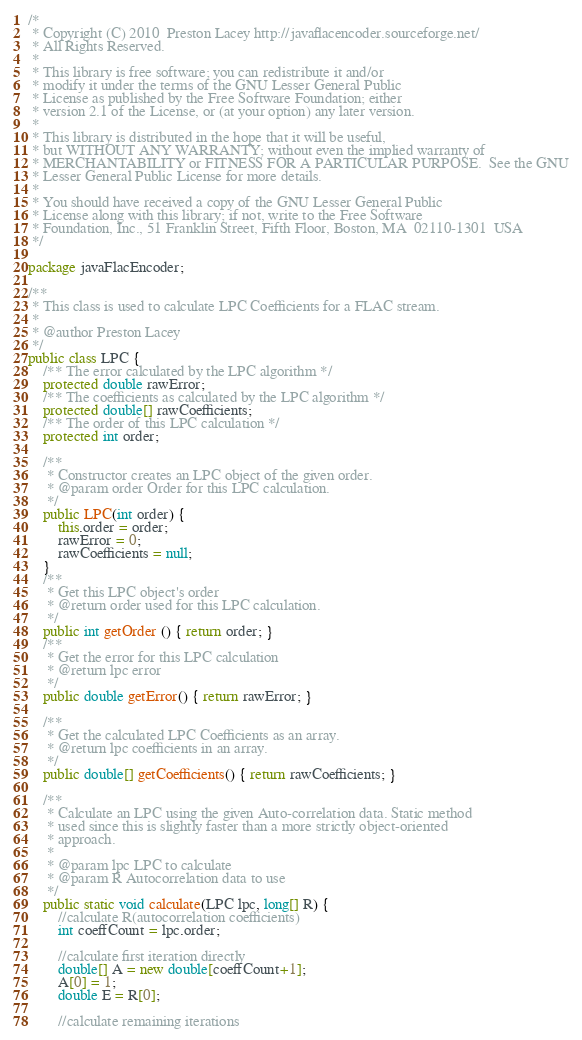<code> <loc_0><loc_0><loc_500><loc_500><_Java_>/*
 * Copyright (C) 2010  Preston Lacey http://javaflacencoder.sourceforge.net/
 * All Rights Reserved.
 *
 * This library is free software; you can redistribute it and/or
 * modify it under the terms of the GNU Lesser General Public
 * License as published by the Free Software Foundation; either
 * version 2.1 of the License, or (at your option) any later version.
 *
 * This library is distributed in the hope that it will be useful,
 * but WITHOUT ANY WARRANTY; without even the implied warranty of
 * MERCHANTABILITY or FITNESS FOR A PARTICULAR PURPOSE.  See the GNU
 * Lesser General Public License for more details.
 *
 * You should have received a copy of the GNU Lesser General Public
 * License along with this library; if not, write to the Free Software
 * Foundation, Inc., 51 Franklin Street, Fifth Floor, Boston, MA  02110-1301  USA
 */

package javaFlacEncoder;

/**
 * This class is used to calculate LPC Coefficients for a FLAC stream.
 *
 * @author Preston Lacey
 */
public class LPC {
    /** The error calculated by the LPC algorithm */
    protected double rawError;
    /** The coefficients as calculated by the LPC algorithm */
    protected double[] rawCoefficients;
    /** The order of this LPC calculation */
    protected int order;

    /**
     * Constructor creates an LPC object of the given order.
     * @param order Order for this LPC calculation.
     */
    public LPC(int order) {
        this.order = order;
        rawError = 0;
        rawCoefficients = null;
    }
    /**
     * Get this LPC object's order
     * @return order used for this LPC calculation.
     */
    public int getOrder () { return order; }
    /**
     * Get the error for this LPC calculation
     * @return lpc error
     */
    public double getError() { return rawError; }

    /**
     * Get the calculated LPC Coefficients as an array.
     * @return lpc coefficients in an array.
     */
    public double[] getCoefficients() { return rawCoefficients; }

    /**
     * Calculate an LPC using the given Auto-correlation data. Static method
     * used since this is slightly faster than a more strictly object-oriented
     * approach.
     * 
     * @param lpc LPC to calculate
     * @param R Autocorrelation data to use
     */
    public static void calculate(LPC lpc, long[] R) {
        //calculate R(autocorrelation coefficients)
        int coeffCount = lpc.order;

        //calculate first iteration directly
        double[] A = new double[coeffCount+1];
        A[0] = 1;
        double E = R[0];

        //calculate remaining iterations
</code> 